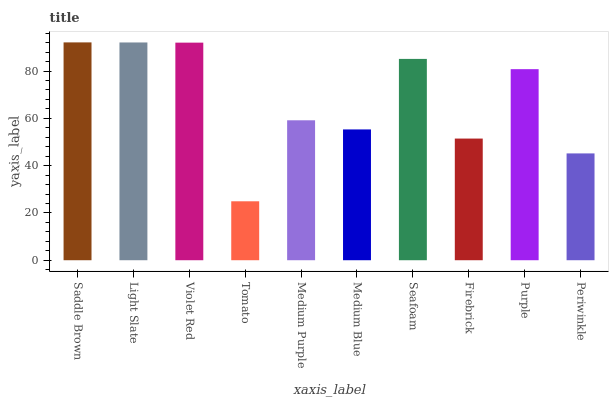Is Tomato the minimum?
Answer yes or no. Yes. Is Saddle Brown the maximum?
Answer yes or no. Yes. Is Light Slate the minimum?
Answer yes or no. No. Is Light Slate the maximum?
Answer yes or no. No. Is Saddle Brown greater than Light Slate?
Answer yes or no. Yes. Is Light Slate less than Saddle Brown?
Answer yes or no. Yes. Is Light Slate greater than Saddle Brown?
Answer yes or no. No. Is Saddle Brown less than Light Slate?
Answer yes or no. No. Is Purple the high median?
Answer yes or no. Yes. Is Medium Purple the low median?
Answer yes or no. Yes. Is Medium Purple the high median?
Answer yes or no. No. Is Seafoam the low median?
Answer yes or no. No. 